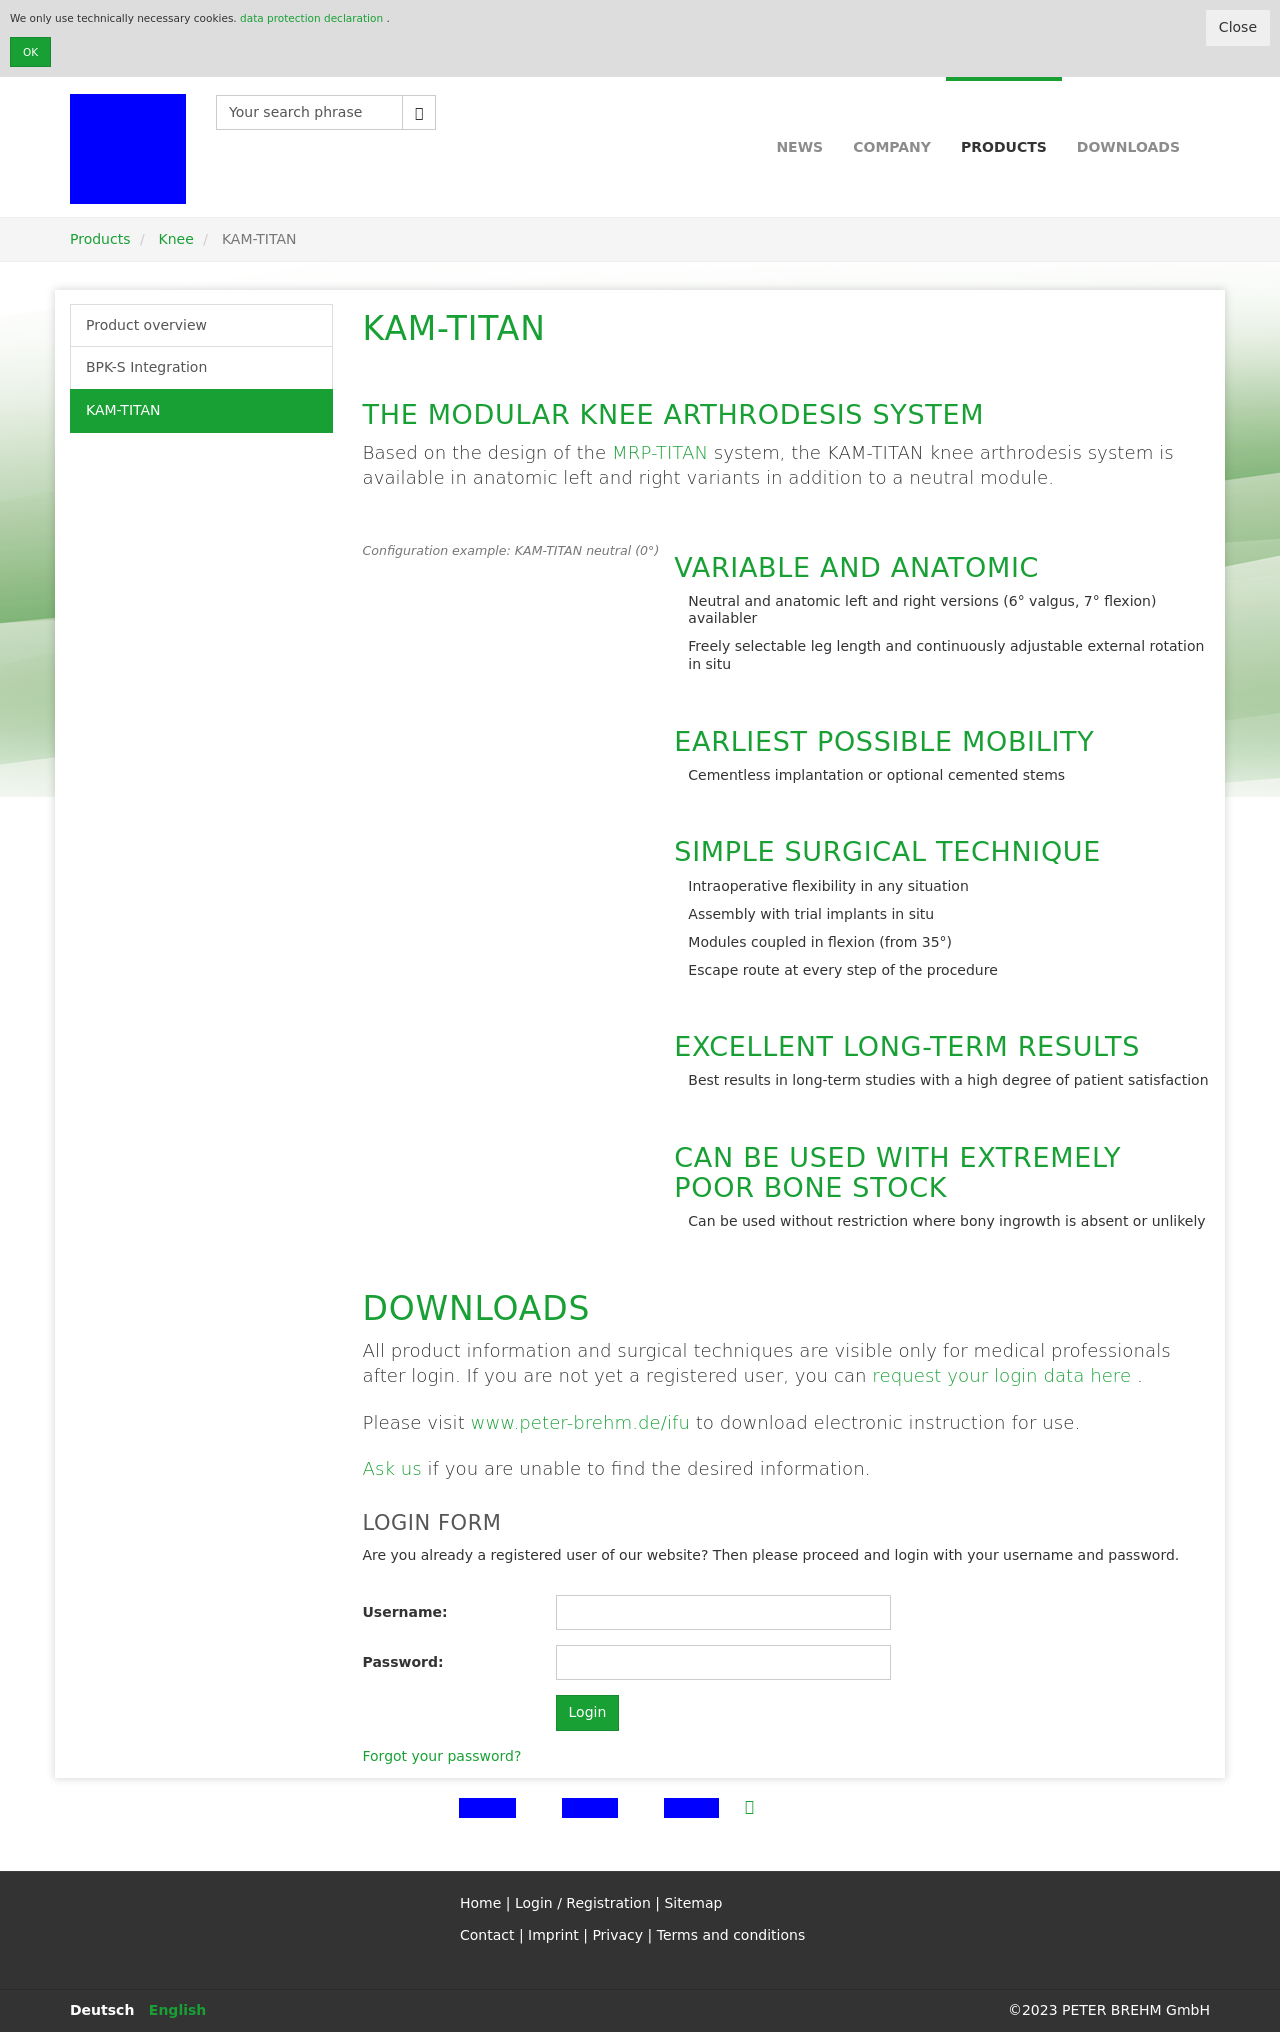Can you explain the significance of the 'Downloads' section mentioned in the image? The 'Downloads' section holds critical importance as it likely provides access to detailed product information and surgical techniques, which are crucial for medical professionals. This resource ensures practitioners have the necessary knowledge and instructions for safe and effective use of the knee system, emphasizing the company's commitment to supporting healthcare professionals through accessible, comprehensive documentation. 